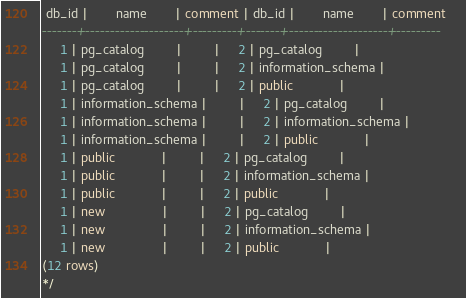Convert code to text. <code><loc_0><loc_0><loc_500><loc_500><_SQL_> db_id |        name        | comment | db_id |        name        | comment 
-------+--------------------+---------+-------+--------------------+---------
     1 | pg_catalog         |         |     2 | pg_catalog         | 
     1 | pg_catalog         |         |     2 | information_schema | 
     1 | pg_catalog         |         |     2 | public             | 
     1 | information_schema |         |     2 | pg_catalog         | 
     1 | information_schema |         |     2 | information_schema | 
     1 | information_schema |         |     2 | public             | 
     1 | public             |         |     2 | pg_catalog         | 
     1 | public             |         |     2 | information_schema | 
     1 | public             |         |     2 | public             | 
     1 | new                |         |     2 | pg_catalog         | 
     1 | new                |         |     2 | information_schema | 
     1 | new                |         |     2 | public             | 
(12 rows)
*/</code> 